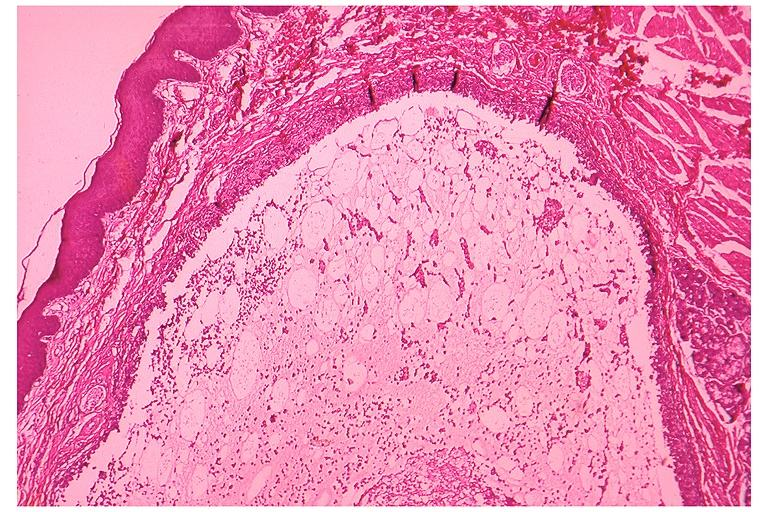what does this image show?
Answer the question using a single word or phrase. Mucocele 